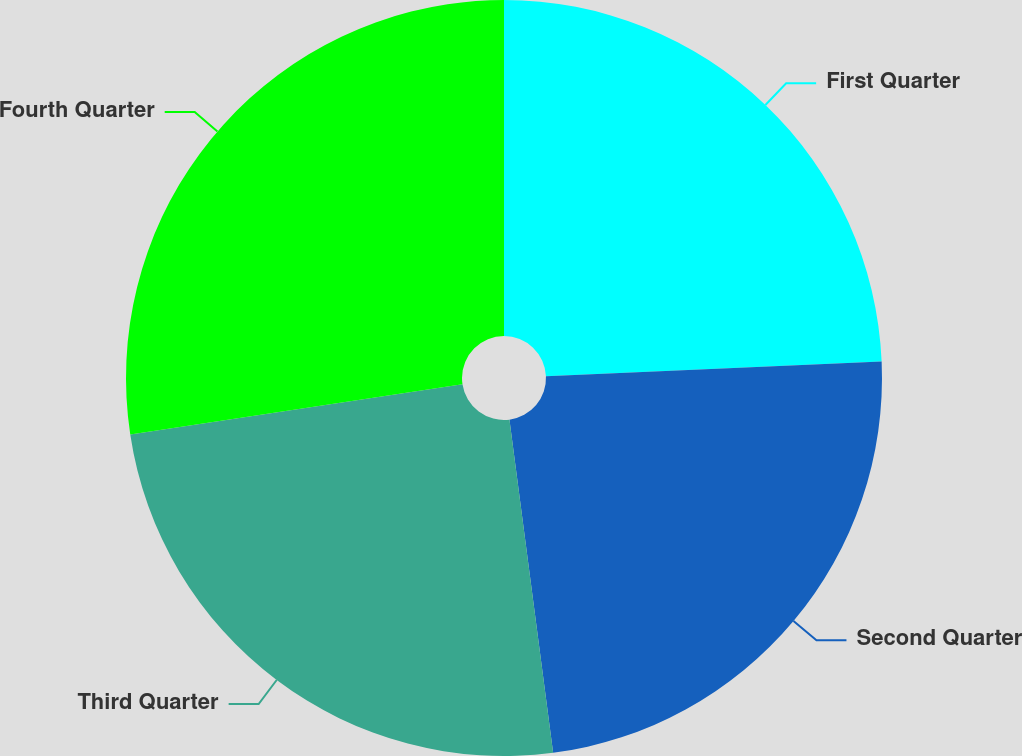Convert chart to OTSL. <chart><loc_0><loc_0><loc_500><loc_500><pie_chart><fcel>First Quarter<fcel>Second Quarter<fcel>Third Quarter<fcel>Fourth Quarter<nl><fcel>24.31%<fcel>23.62%<fcel>24.69%<fcel>27.39%<nl></chart> 